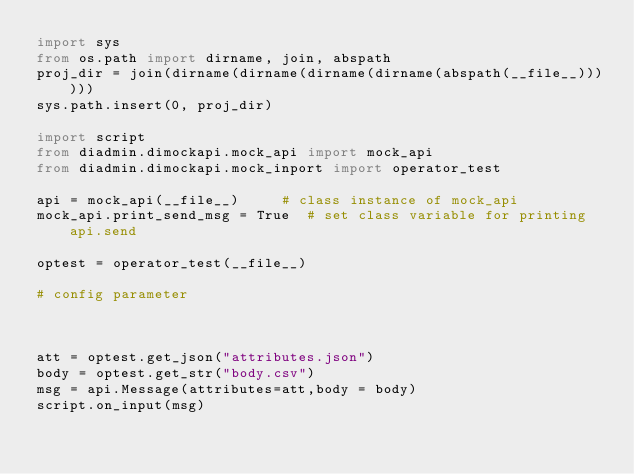<code> <loc_0><loc_0><loc_500><loc_500><_Python_>import sys
from os.path import dirname, join, abspath
proj_dir = join(dirname(dirname(dirname(dirname(abspath(__file__))))))
sys.path.insert(0, proj_dir)

import script
from diadmin.dimockapi.mock_api import mock_api
from diadmin.dimockapi.mock_inport import operator_test

api = mock_api(__file__)     # class instance of mock_api
mock_api.print_send_msg = True  # set class variable for printing api.send

optest = operator_test(__file__)

# config parameter



att = optest.get_json("attributes.json")
body = optest.get_str("body.csv")
msg = api.Message(attributes=att,body = body)
script.on_input(msg)
</code> 